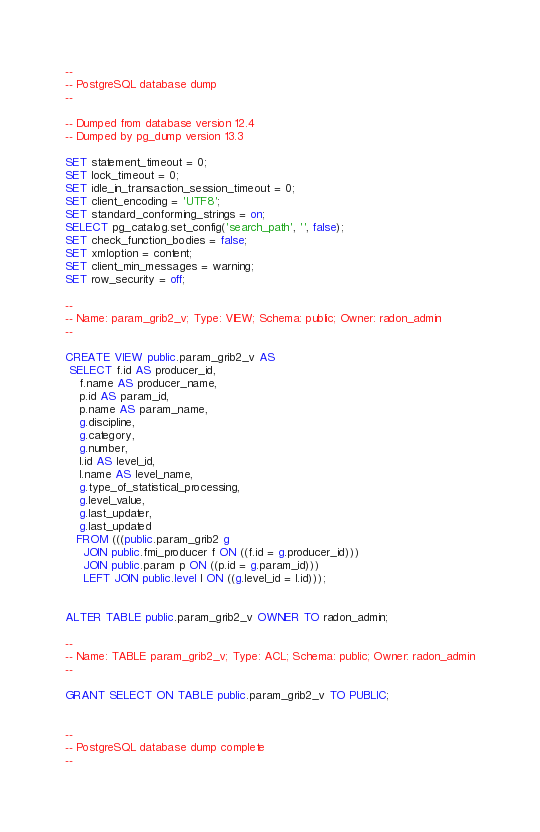<code> <loc_0><loc_0><loc_500><loc_500><_SQL_>--
-- PostgreSQL database dump
--

-- Dumped from database version 12.4
-- Dumped by pg_dump version 13.3

SET statement_timeout = 0;
SET lock_timeout = 0;
SET idle_in_transaction_session_timeout = 0;
SET client_encoding = 'UTF8';
SET standard_conforming_strings = on;
SELECT pg_catalog.set_config('search_path', '', false);
SET check_function_bodies = false;
SET xmloption = content;
SET client_min_messages = warning;
SET row_security = off;

--
-- Name: param_grib2_v; Type: VIEW; Schema: public; Owner: radon_admin
--

CREATE VIEW public.param_grib2_v AS
 SELECT f.id AS producer_id,
    f.name AS producer_name,
    p.id AS param_id,
    p.name AS param_name,
    g.discipline,
    g.category,
    g.number,
    l.id AS level_id,
    l.name AS level_name,
    g.type_of_statistical_processing,
    g.level_value,
    g.last_updater,
    g.last_updated
   FROM (((public.param_grib2 g
     JOIN public.fmi_producer f ON ((f.id = g.producer_id)))
     JOIN public.param p ON ((p.id = g.param_id)))
     LEFT JOIN public.level l ON ((g.level_id = l.id)));


ALTER TABLE public.param_grib2_v OWNER TO radon_admin;

--
-- Name: TABLE param_grib2_v; Type: ACL; Schema: public; Owner: radon_admin
--

GRANT SELECT ON TABLE public.param_grib2_v TO PUBLIC;


--
-- PostgreSQL database dump complete
--

</code> 